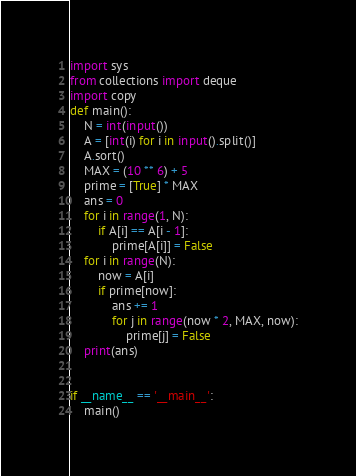Convert code to text. <code><loc_0><loc_0><loc_500><loc_500><_Python_>import sys
from collections import deque
import copy
def main():
    N = int(input())
    A = [int(i) for i in input().split()]
    A.sort()
    MAX = (10 ** 6) + 5
    prime = [True] * MAX
    ans = 0
    for i in range(1, N):
        if A[i] == A[i - 1]:
            prime[A[i]] = False
    for i in range(N):
        now = A[i]
        if prime[now]:
            ans += 1
            for j in range(now * 2, MAX, now):
                prime[j] = False
    print(ans)


if __name__ == '__main__':
    main()
</code> 